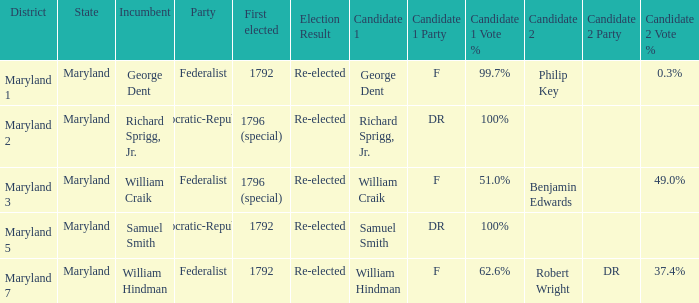0%? Maryland 3. 